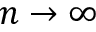Convert formula to latex. <formula><loc_0><loc_0><loc_500><loc_500>n \to \infty</formula> 